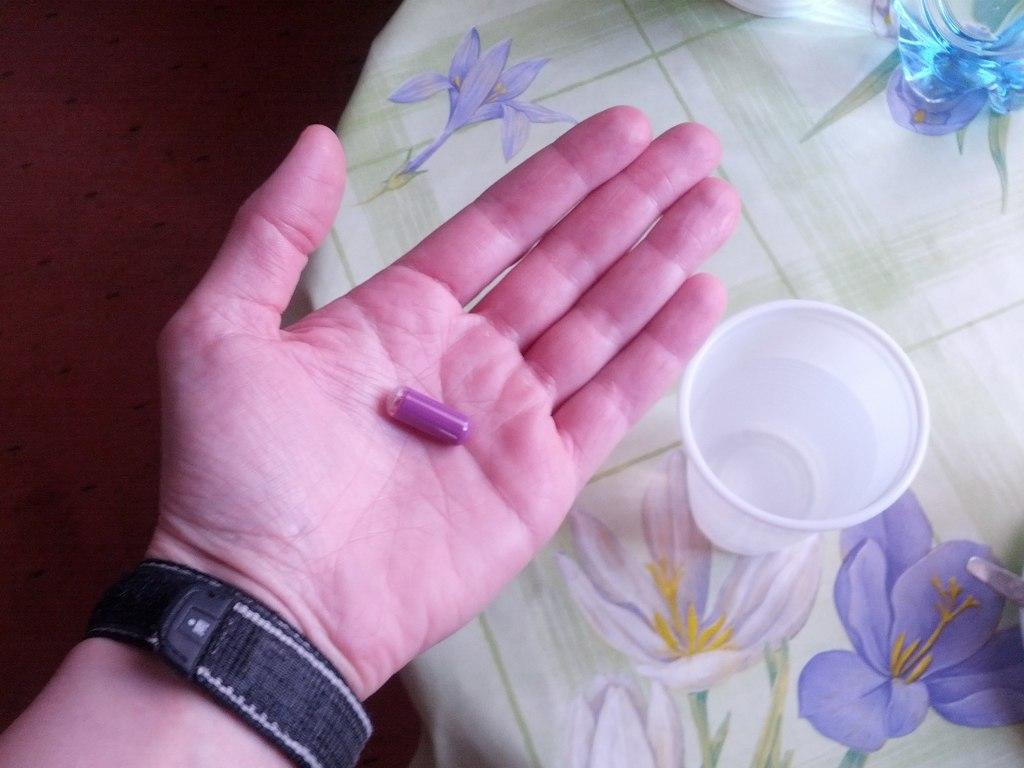What is being held by the person's hand in the image? There is a person's hand with a capsule in the image. What can be seen on the table in the image? There is a glass with water and a cloth on the table in the image. What part of the room is visible on the left side of the image? The floor is visible on the left side of the image. What type of legal advice is the person's tongue providing in the image? There is no person's tongue or lawyer present in the image, so no legal advice can be provided. 